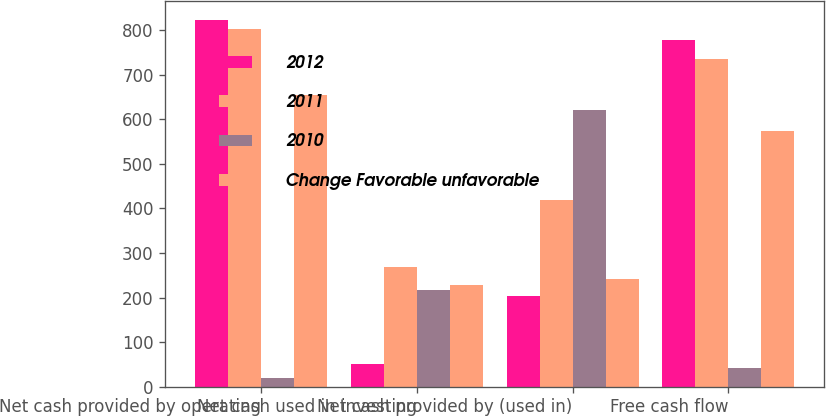Convert chart to OTSL. <chart><loc_0><loc_0><loc_500><loc_500><stacked_bar_chart><ecel><fcel>Net cash provided by operating<fcel>Net cash used in investing<fcel>Net cash provided by (used in)<fcel>Free cash flow<nl><fcel>2012<fcel>823.1<fcel>50.2<fcel>202.6<fcel>778.1<nl><fcel>2011<fcel>803.3<fcel>267.6<fcel>417.7<fcel>735.6<nl><fcel>2010<fcel>19.8<fcel>217.4<fcel>620.3<fcel>42.5<nl><fcel>Change Favorable unfavorable<fcel>653.3<fcel>228.8<fcel>241.3<fcel>574.3<nl></chart> 